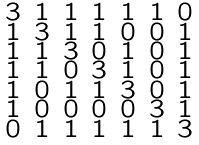Convert formula to latex. <formula><loc_0><loc_0><loc_500><loc_500>\begin{smallmatrix} 3 & 1 & 1 & 1 & 1 & 1 & 0 \\ 1 & 3 & 1 & 1 & 0 & 0 & 1 \\ 1 & 1 & 3 & 0 & 1 & 0 & 1 \\ 1 & 1 & 0 & 3 & 1 & 0 & 1 \\ 1 & 0 & 1 & 1 & 3 & 0 & 1 \\ 1 & 0 & 0 & 0 & 0 & 3 & 1 \\ 0 & 1 & 1 & 1 & 1 & 1 & 3 \end{smallmatrix}</formula> 